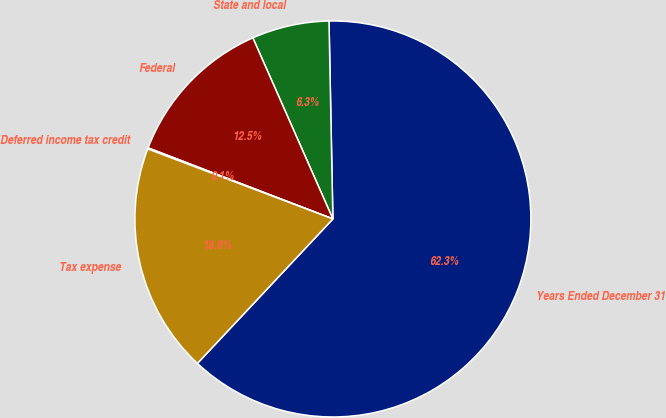<chart> <loc_0><loc_0><loc_500><loc_500><pie_chart><fcel>Years Ended December 31<fcel>State and local<fcel>Federal<fcel>Deferred income tax credit<fcel>Tax expense<nl><fcel>62.3%<fcel>6.31%<fcel>12.53%<fcel>0.09%<fcel>18.76%<nl></chart> 